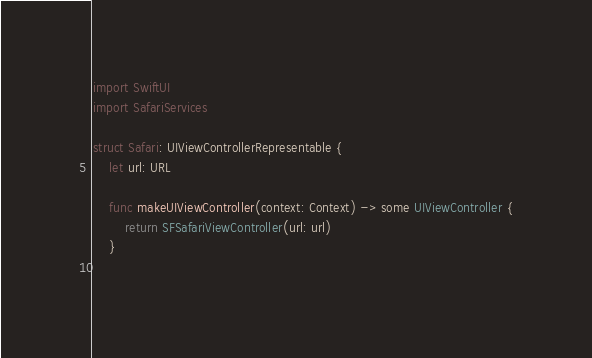Convert code to text. <code><loc_0><loc_0><loc_500><loc_500><_Swift_>import SwiftUI
import SafariServices

struct Safari: UIViewControllerRepresentable {
    let url: URL
    
    func makeUIViewController(context: Context) -> some UIViewController {
        return SFSafariViewController(url: url)
    }
    </code> 